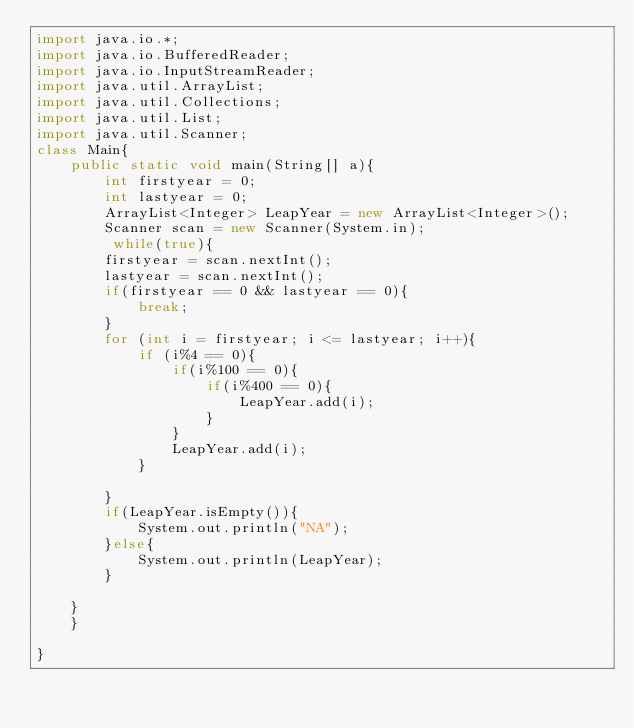<code> <loc_0><loc_0><loc_500><loc_500><_Java_>import java.io.*;
import java.io.BufferedReader;
import java.io.InputStreamReader;
import java.util.ArrayList;
import java.util.Collections;
import java.util.List;
import java.util.Scanner;
class Main{
    public static void main(String[] a){
    	int firstyear = 0;
    	int lastyear = 0;
    	ArrayList<Integer> LeapYear = new ArrayList<Integer>();
    	Scanner scan = new Scanner(System.in);
    	 while(true){
    	firstyear = scan.nextInt();
    	lastyear = scan.nextInt();
    	if(firstyear == 0 && lastyear == 0){
    		break;
    	}
    	for (int i = firstyear; i <= lastyear; i++){
    		if (i%4 == 0){
    			if(i%100 == 0){
    				if(i%400 == 0){
    					LeapYear.add(i);
    				}
    			}
    			LeapYear.add(i);
    		}
    		
    	}
    	if(LeapYear.isEmpty()){
    		System.out.println("NA");
    	}else{
    		System.out.println(LeapYear);
    	}
    	
    }
    }
    
}</code> 